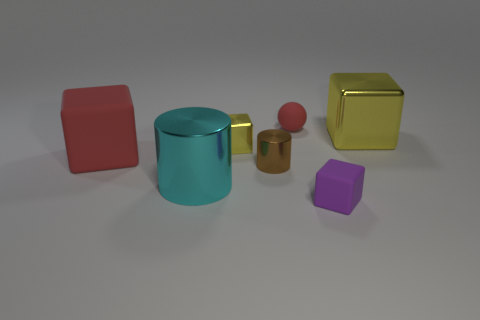There is a shiny cylinder that is to the right of the cyan cylinder; is it the same size as the tiny red matte object?
Your answer should be compact. Yes. Is the number of rubber things to the right of the tiny red thing greater than the number of purple metal spheres?
Keep it short and to the point. Yes. What number of purple matte blocks are to the right of the small matte object that is behind the cyan cylinder?
Give a very brief answer. 1. Is the number of tiny shiny cylinders in front of the big cyan thing less than the number of small purple cubes?
Offer a very short reply. Yes. Is there a tiny shiny block right of the yellow object that is left of the tiny cube that is in front of the tiny yellow shiny cube?
Provide a short and direct response. No. Is the material of the purple cube the same as the object that is left of the big cyan metal thing?
Offer a terse response. Yes. There is a big cube that is to the right of the tiny cube that is to the right of the small yellow object; what color is it?
Keep it short and to the point. Yellow. Are there any rubber objects of the same color as the tiny rubber cube?
Offer a terse response. No. There is a yellow thing that is in front of the yellow block on the right side of the tiny matte block that is in front of the large cyan object; how big is it?
Give a very brief answer. Small. There is a big cyan metal object; is its shape the same as the small matte object that is to the left of the purple rubber thing?
Provide a short and direct response. No. 